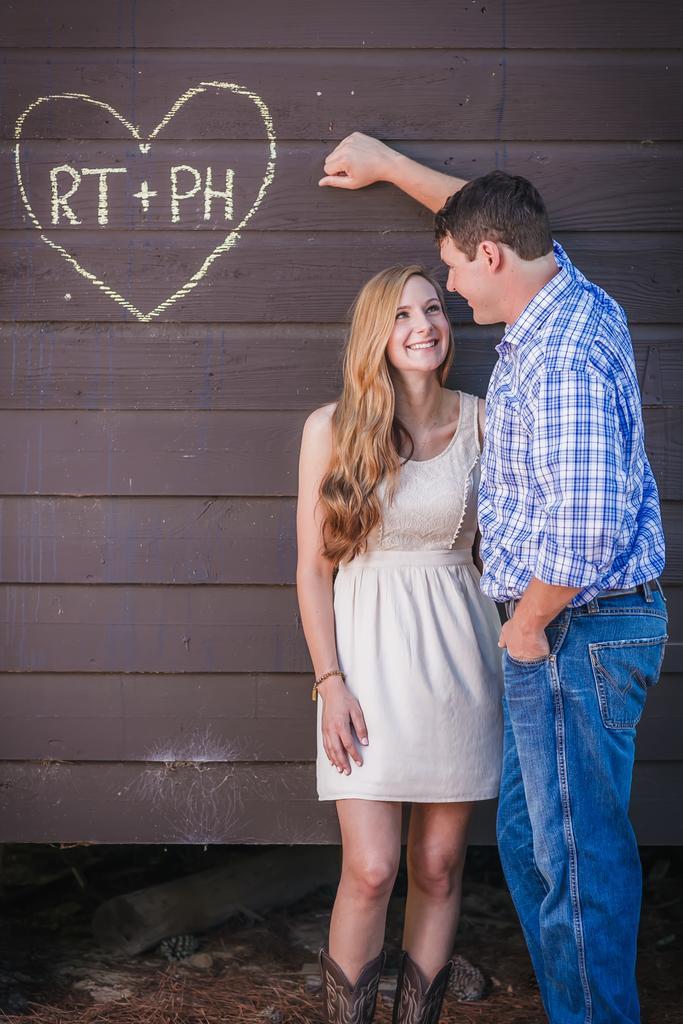In one or two sentences, can you explain what this image depicts? In this image we can see a couple who are wearing blue color and white color dress respectively standing near the wall and the wall is of brown color and there is some symbol and some text is written on it. 